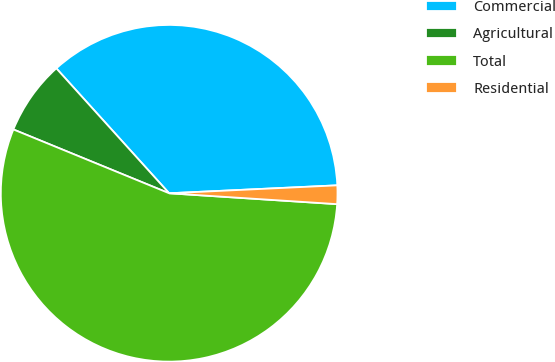Convert chart to OTSL. <chart><loc_0><loc_0><loc_500><loc_500><pie_chart><fcel>Commercial<fcel>Agricultural<fcel>Total<fcel>Residential<nl><fcel>35.94%<fcel>7.12%<fcel>55.16%<fcel>1.78%<nl></chart> 